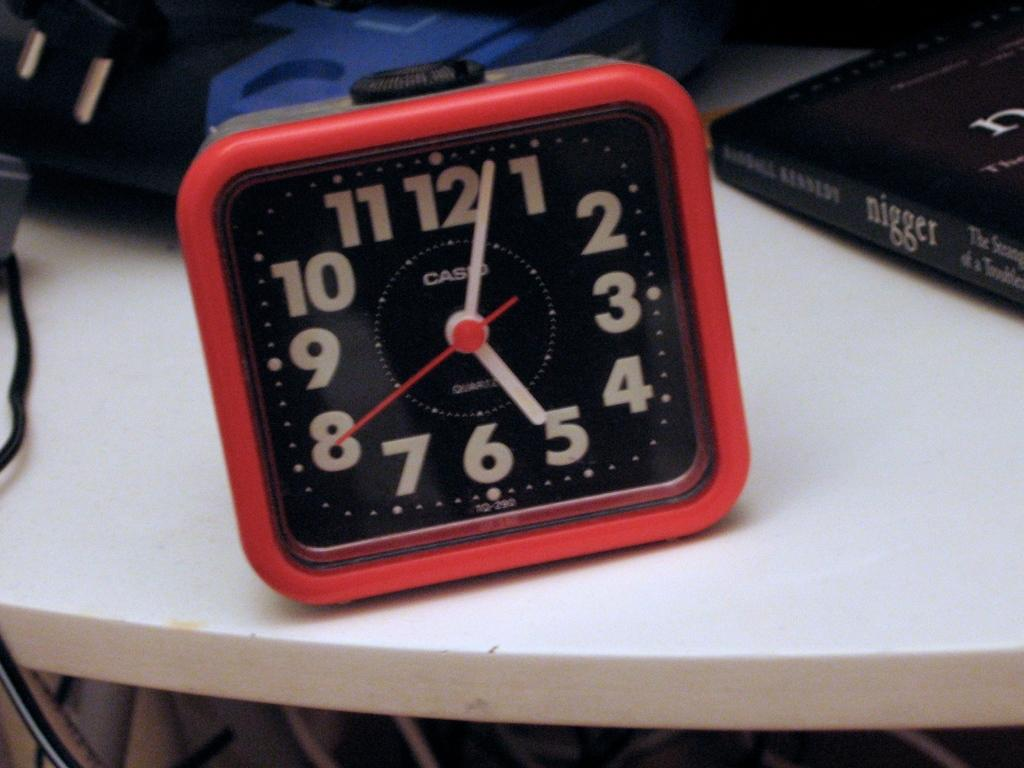<image>
Summarize the visual content of the image. A red casio clock sits on a desk . 